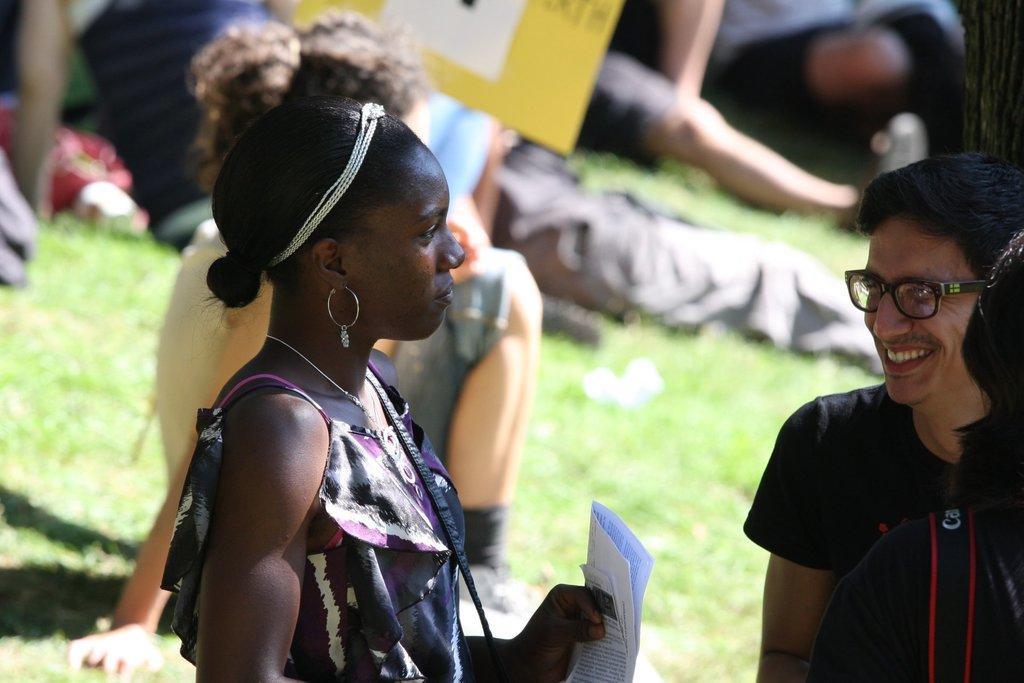Can you describe this image briefly? In this image there is a woman holding few papers. There are people on the grassland. Right side there is a person wearing spectacles. Top of the image there is a board. 